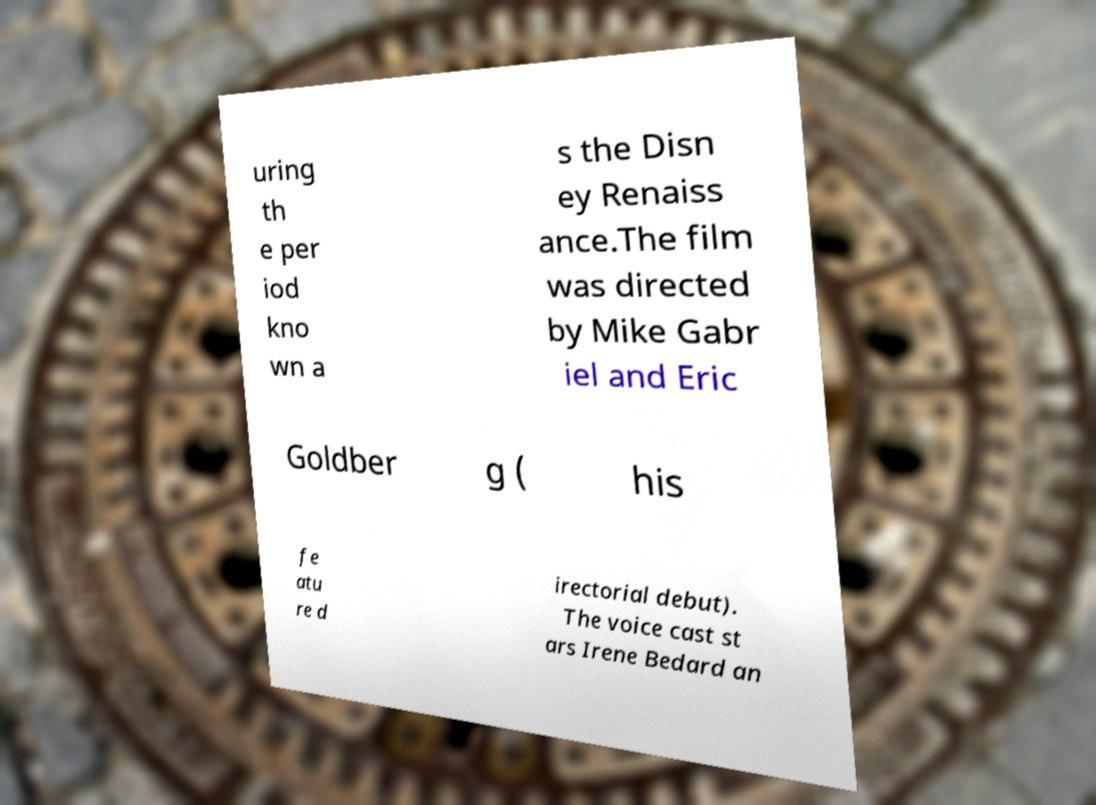Can you read and provide the text displayed in the image?This photo seems to have some interesting text. Can you extract and type it out for me? uring th e per iod kno wn a s the Disn ey Renaiss ance.The film was directed by Mike Gabr iel and Eric Goldber g ( his fe atu re d irectorial debut). The voice cast st ars Irene Bedard an 